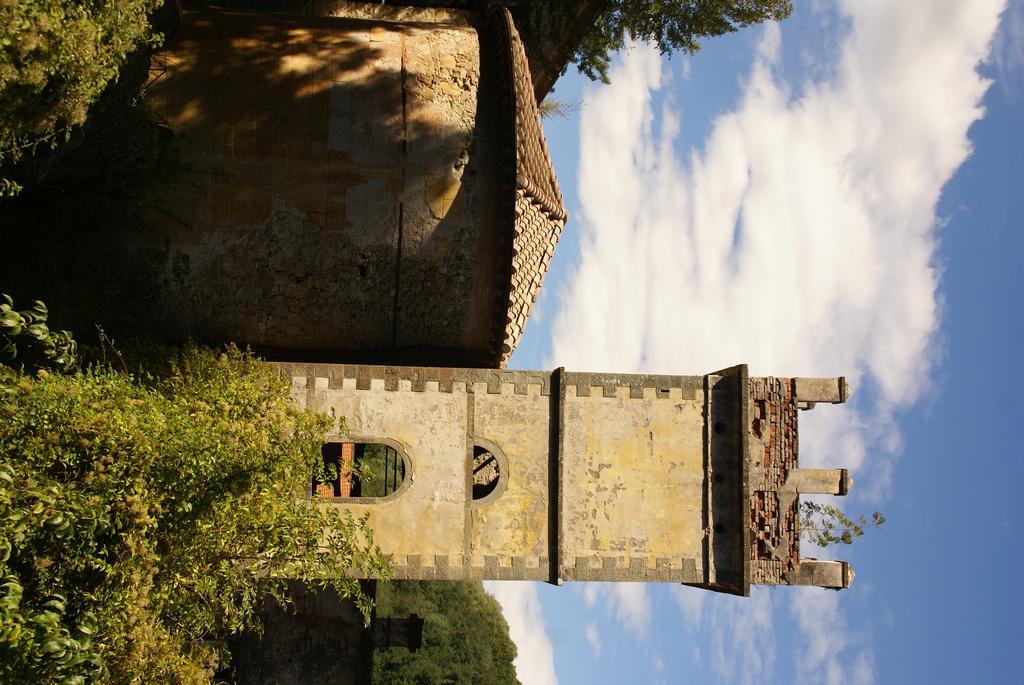Describe this image in one or two sentences. In this image there is a tower and a shed. We can see trees. In the background there is sky. 